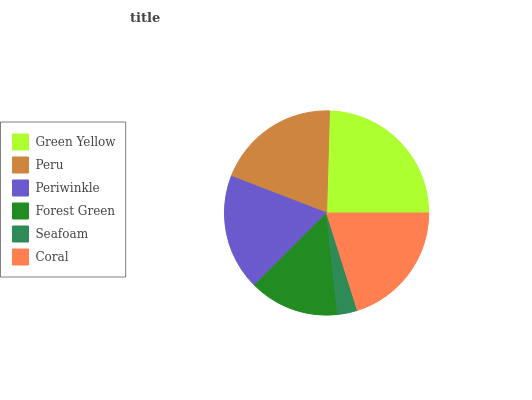Is Seafoam the minimum?
Answer yes or no. Yes. Is Green Yellow the maximum?
Answer yes or no. Yes. Is Peru the minimum?
Answer yes or no. No. Is Peru the maximum?
Answer yes or no. No. Is Green Yellow greater than Peru?
Answer yes or no. Yes. Is Peru less than Green Yellow?
Answer yes or no. Yes. Is Peru greater than Green Yellow?
Answer yes or no. No. Is Green Yellow less than Peru?
Answer yes or no. No. Is Peru the high median?
Answer yes or no. Yes. Is Periwinkle the low median?
Answer yes or no. Yes. Is Periwinkle the high median?
Answer yes or no. No. Is Peru the low median?
Answer yes or no. No. 